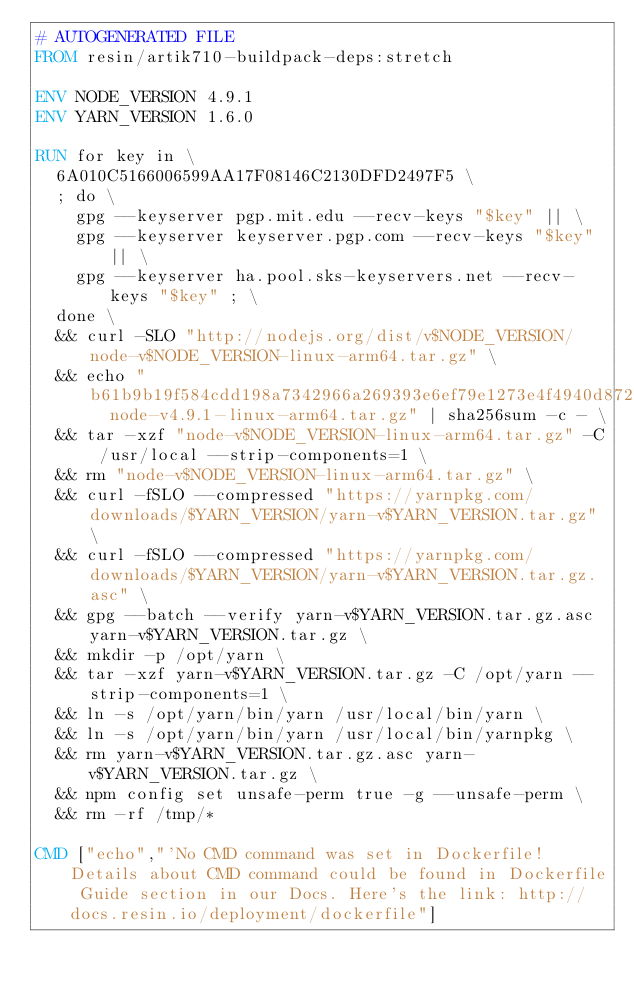<code> <loc_0><loc_0><loc_500><loc_500><_Dockerfile_># AUTOGENERATED FILE
FROM resin/artik710-buildpack-deps:stretch

ENV NODE_VERSION 4.9.1
ENV YARN_VERSION 1.6.0

RUN for key in \
	6A010C5166006599AA17F08146C2130DFD2497F5 \
	; do \
		gpg --keyserver pgp.mit.edu --recv-keys "$key" || \
		gpg --keyserver keyserver.pgp.com --recv-keys "$key" || \
		gpg --keyserver ha.pool.sks-keyservers.net --recv-keys "$key" ; \
	done \
	&& curl -SLO "http://nodejs.org/dist/v$NODE_VERSION/node-v$NODE_VERSION-linux-arm64.tar.gz" \
	&& echo "b61b9b19f584cdd198a7342966a269393e6ef79e1273e4f4940d872b929d8403  node-v4.9.1-linux-arm64.tar.gz" | sha256sum -c - \
	&& tar -xzf "node-v$NODE_VERSION-linux-arm64.tar.gz" -C /usr/local --strip-components=1 \
	&& rm "node-v$NODE_VERSION-linux-arm64.tar.gz" \
	&& curl -fSLO --compressed "https://yarnpkg.com/downloads/$YARN_VERSION/yarn-v$YARN_VERSION.tar.gz" \
	&& curl -fSLO --compressed "https://yarnpkg.com/downloads/$YARN_VERSION/yarn-v$YARN_VERSION.tar.gz.asc" \
	&& gpg --batch --verify yarn-v$YARN_VERSION.tar.gz.asc yarn-v$YARN_VERSION.tar.gz \
	&& mkdir -p /opt/yarn \
	&& tar -xzf yarn-v$YARN_VERSION.tar.gz -C /opt/yarn --strip-components=1 \
	&& ln -s /opt/yarn/bin/yarn /usr/local/bin/yarn \
	&& ln -s /opt/yarn/bin/yarn /usr/local/bin/yarnpkg \
	&& rm yarn-v$YARN_VERSION.tar.gz.asc yarn-v$YARN_VERSION.tar.gz \
	&& npm config set unsafe-perm true -g --unsafe-perm \
	&& rm -rf /tmp/*

CMD ["echo","'No CMD command was set in Dockerfile! Details about CMD command could be found in Dockerfile Guide section in our Docs. Here's the link: http://docs.resin.io/deployment/dockerfile"]
</code> 